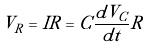<formula> <loc_0><loc_0><loc_500><loc_500>V _ { R } = I R = C \frac { d V _ { C } } { d t } R</formula> 